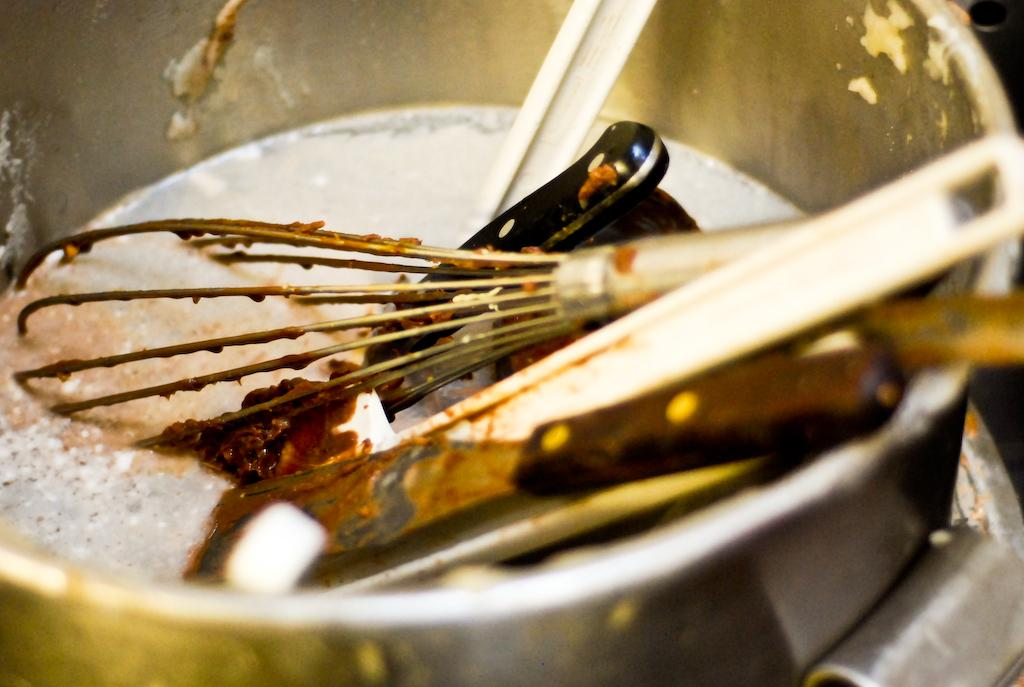What is present in the image that resembles a container? There is a bowl in the image. What utensil can be seen in the bowl? There is a knife in the bowl. What other utensils are present in the bowl? There are spoons in the bowl. Can you see a bear swimming with a goldfish in the bowl? No, there is no bear or goldfish present in the bowl; it contains a knife and spoons. What type of building is visible in the image? There is no building visible in the image; it only features a bowl with utensils. 